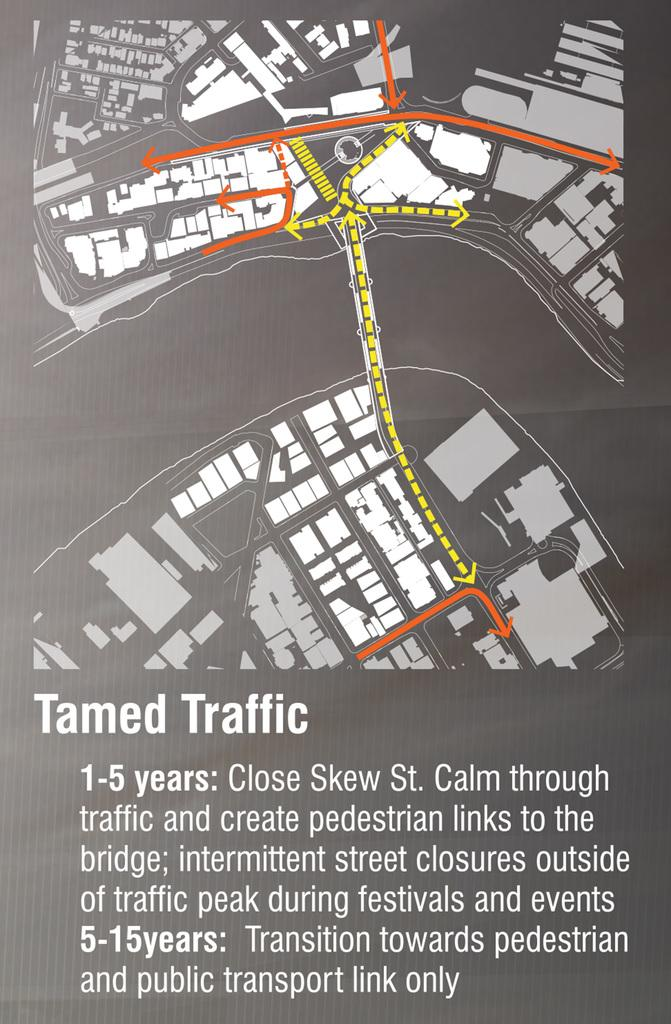What is featured on the poster in the image? The poster contains a map and text. What type of information might be conveyed by the map on the poster? The map on the poster might convey geographical information or directions. What other element is present on the poster besides the map? The poster also contains text. What type of winter activity is depicted on the poster? There is no winter activity depicted on the poster; it contains a map and text. How does the rake relate to the poster's content? There is no rake present in the image or mentioned in the facts provided. 